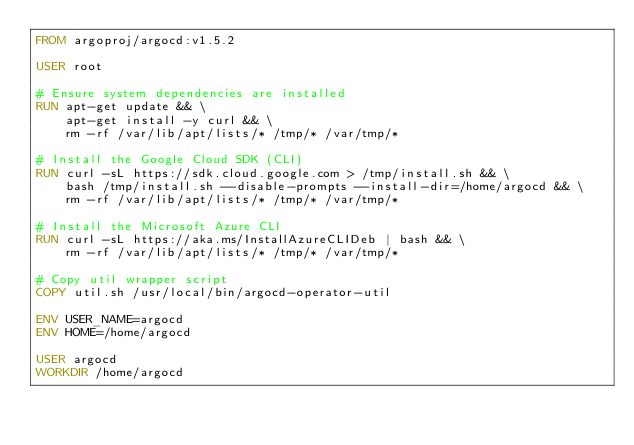<code> <loc_0><loc_0><loc_500><loc_500><_Dockerfile_>FROM argoproj/argocd:v1.5.2

USER root

# Ensure system dependencies are installed
RUN apt-get update && \
    apt-get install -y curl && \
    rm -rf /var/lib/apt/lists/* /tmp/* /var/tmp/*

# Install the Google Cloud SDK (CLI)
RUN curl -sL https://sdk.cloud.google.com > /tmp/install.sh && \
    bash /tmp/install.sh --disable-prompts --install-dir=/home/argocd && \
    rm -rf /var/lib/apt/lists/* /tmp/* /var/tmp/*

# Install the Microsoft Azure CLI
RUN curl -sL https://aka.ms/InstallAzureCLIDeb | bash && \
    rm -rf /var/lib/apt/lists/* /tmp/* /var/tmp/*

# Copy util wrapper script
COPY util.sh /usr/local/bin/argocd-operator-util

ENV USER_NAME=argocd
ENV HOME=/home/argocd

USER argocd
WORKDIR /home/argocd
</code> 